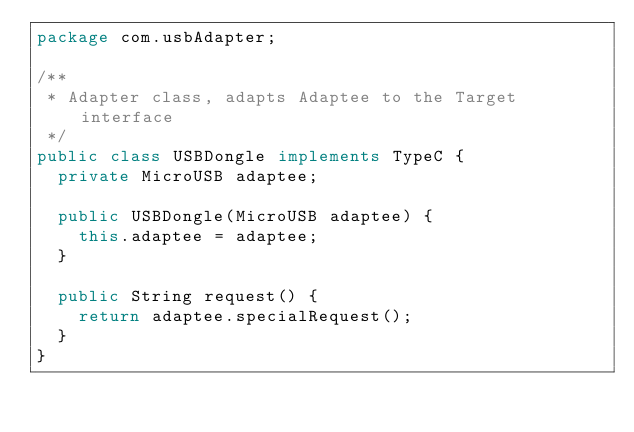<code> <loc_0><loc_0><loc_500><loc_500><_Java_>package com.usbAdapter;

/**
 * Adapter class, adapts Adaptee to the Target interface
 */
public class USBDongle implements TypeC {
  private MicroUSB adaptee;

  public USBDongle(MicroUSB adaptee) {
    this.adaptee = adaptee;
  }

  public String request() {
    return adaptee.specialRequest();
  }
}
</code> 